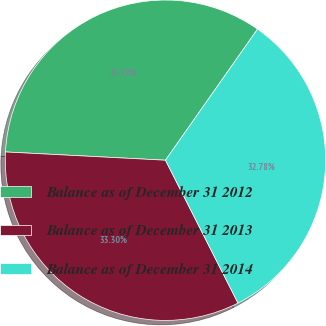Convert chart. <chart><loc_0><loc_0><loc_500><loc_500><pie_chart><fcel>Balance as of December 31 2012<fcel>Balance as of December 31 2013<fcel>Balance as of December 31 2014<nl><fcel>33.92%<fcel>33.3%<fcel>32.78%<nl></chart> 